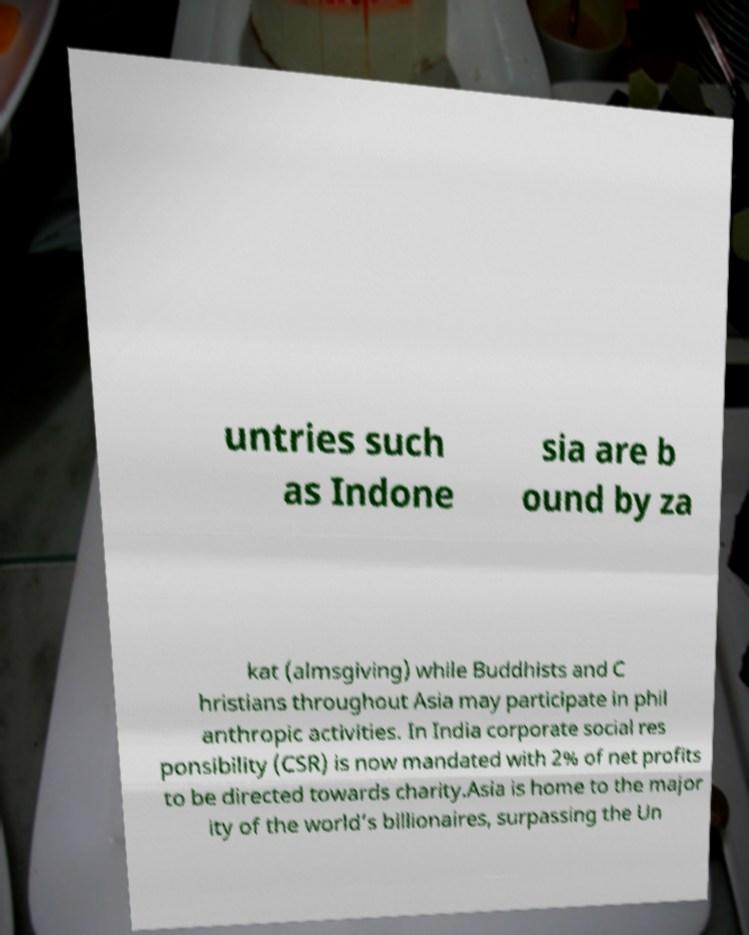Could you extract and type out the text from this image? untries such as Indone sia are b ound by za kat (almsgiving) while Buddhists and C hristians throughout Asia may participate in phil anthropic activities. In India corporate social res ponsibility (CSR) is now mandated with 2% of net profits to be directed towards charity.Asia is home to the major ity of the world’s billionaires, surpassing the Un 